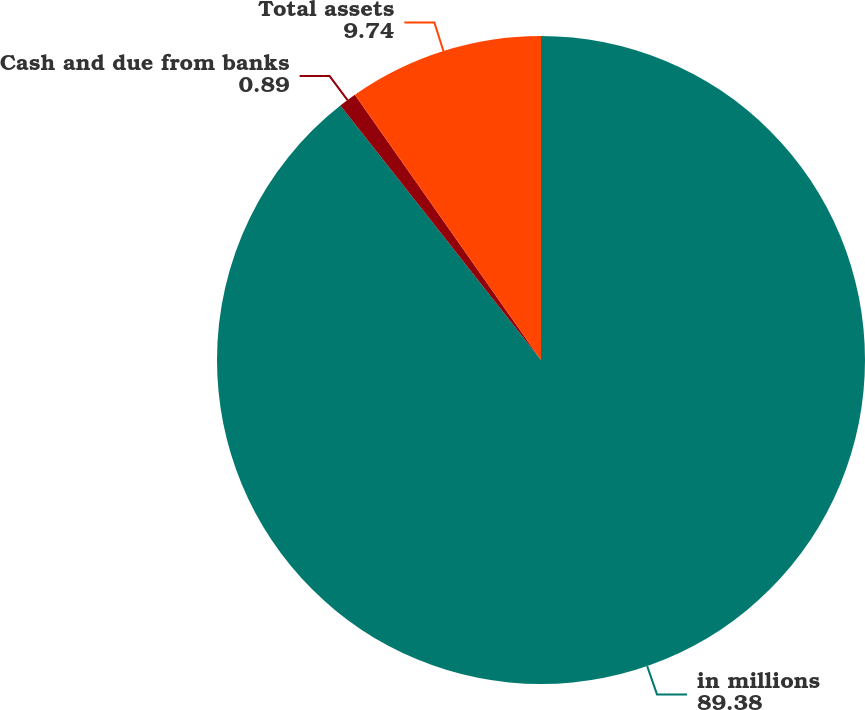Convert chart to OTSL. <chart><loc_0><loc_0><loc_500><loc_500><pie_chart><fcel>in millions<fcel>Cash and due from banks<fcel>Total assets<nl><fcel>89.38%<fcel>0.89%<fcel>9.74%<nl></chart> 